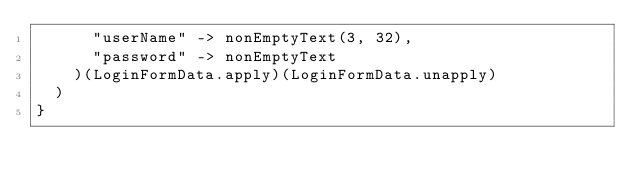Convert code to text. <code><loc_0><loc_0><loc_500><loc_500><_Scala_>      "userName" -> nonEmptyText(3, 32),
      "password" -> nonEmptyText
    )(LoginFormData.apply)(LoginFormData.unapply)
  )
}
</code> 